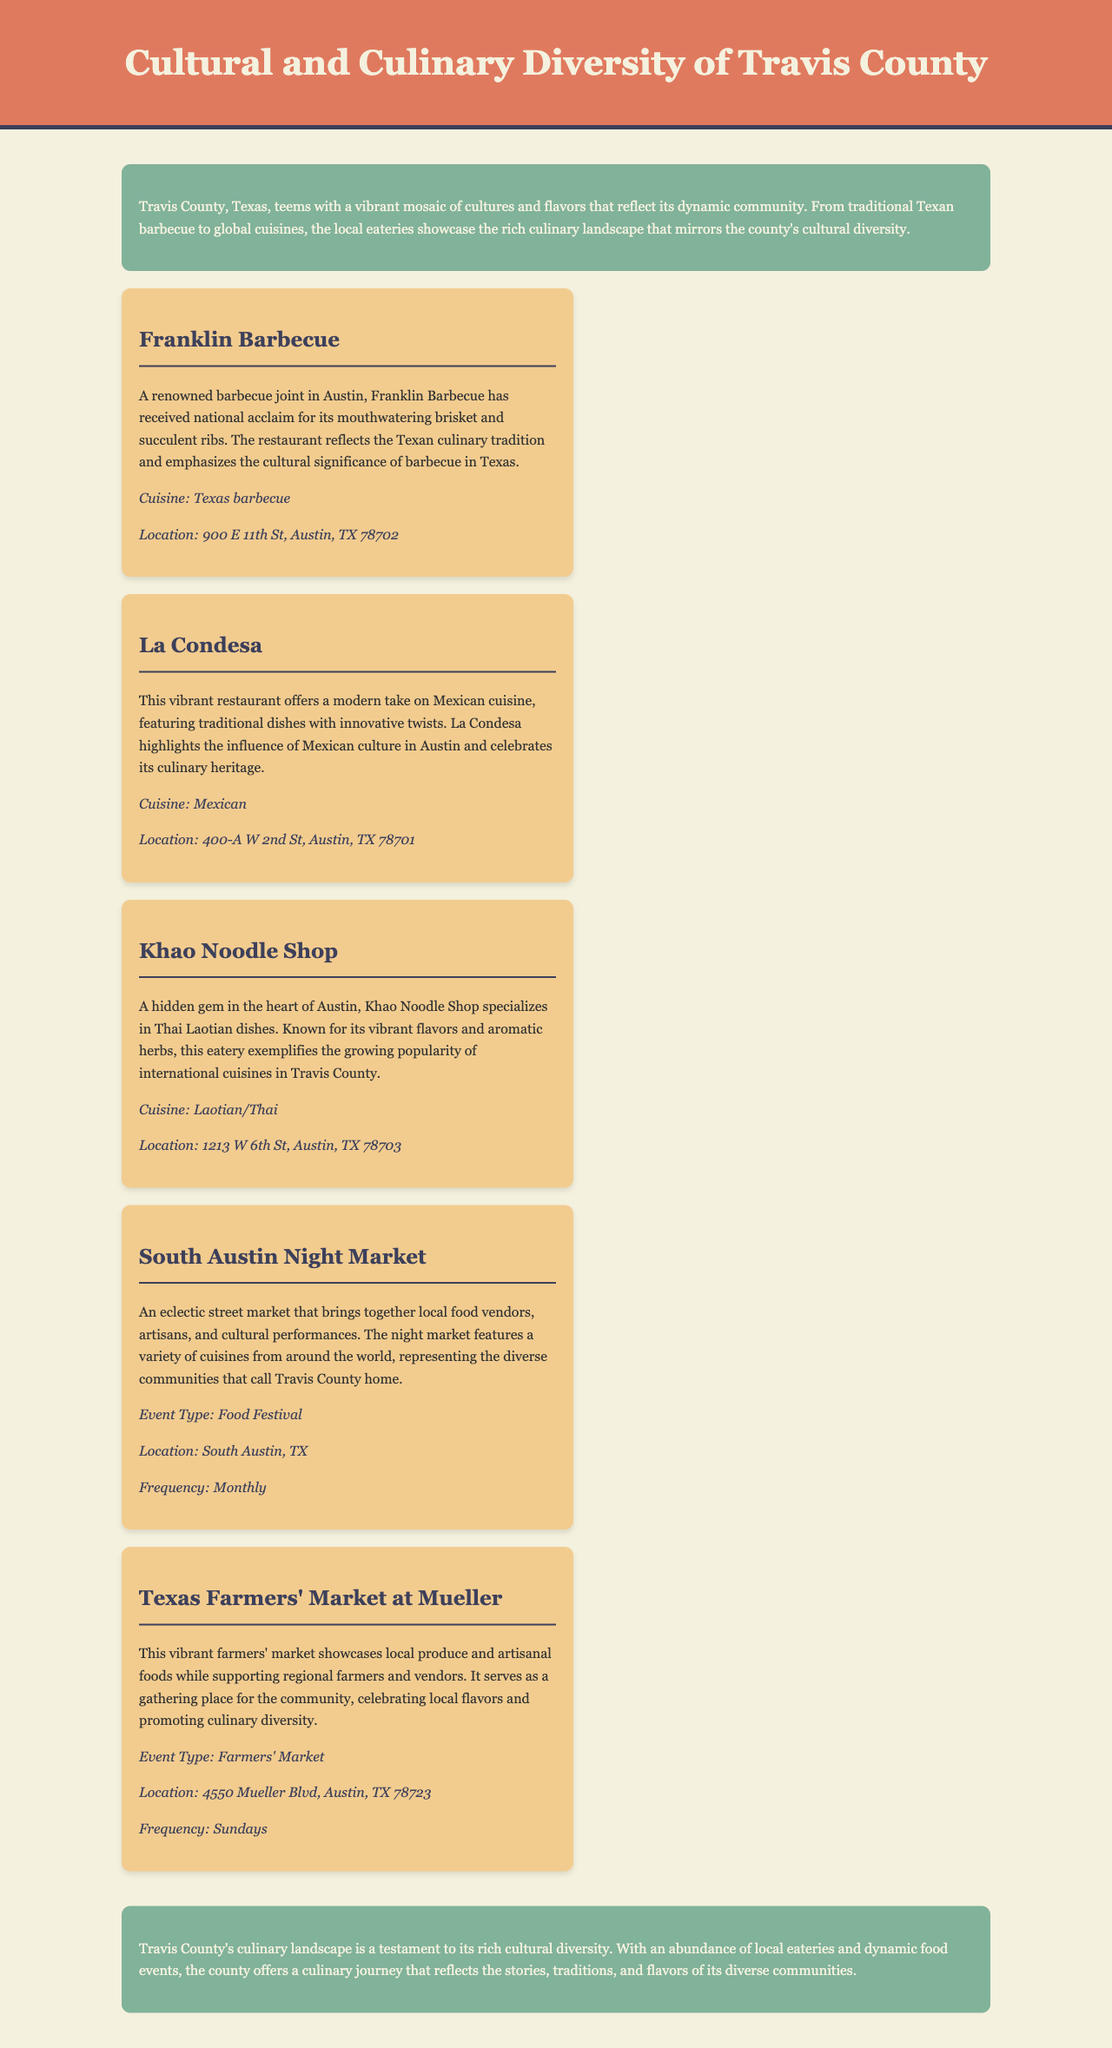What cuisine is offered at Franklin Barbecue? Franklin Barbecue specializes in Texas barbecue, which is highlighted in the document.
Answer: Texas barbecue Where is La Condesa located? The document provides the address for La Condesa, which is mentioned in the key points section.
Answer: 400-A W 2nd St, Austin, TX 78701 What type of event is the South Austin Night Market? The document categorizes the South Austin Night Market as a food festival, as indicated in the event type section.
Answer: Food Festival How often does the Texas Farmers' Market at Mueller occur? The frequency of the Texas Farmers' Market is specified in the document, indicating how often it takes place.
Answer: Sundays What dish is Khao Noodle Shop known for? The document highlights that Khao Noodle Shop is known for its Thai Laotian dishes, providing information about the restaurant's specialty.
Answer: Thai Laotian dishes What is the primary focus of the document? The document centers on the cultural and culinary diversity of Travis County, summarizing its main theme.
Answer: Cultural and culinary diversity What is a key feature of the South Austin Night Market? The document notes that the South Austin Night Market features local food vendors and cultural performances, which is a significant detail about the event.
Answer: Local food vendors and cultural performances What does the introduction emphasize about Travis County? The introduction highlights the vibrant mosaic of cultures and flavors in Travis County, summarizing the county's cultural richness.
Answer: A vibrant mosaic of cultures and flavors 